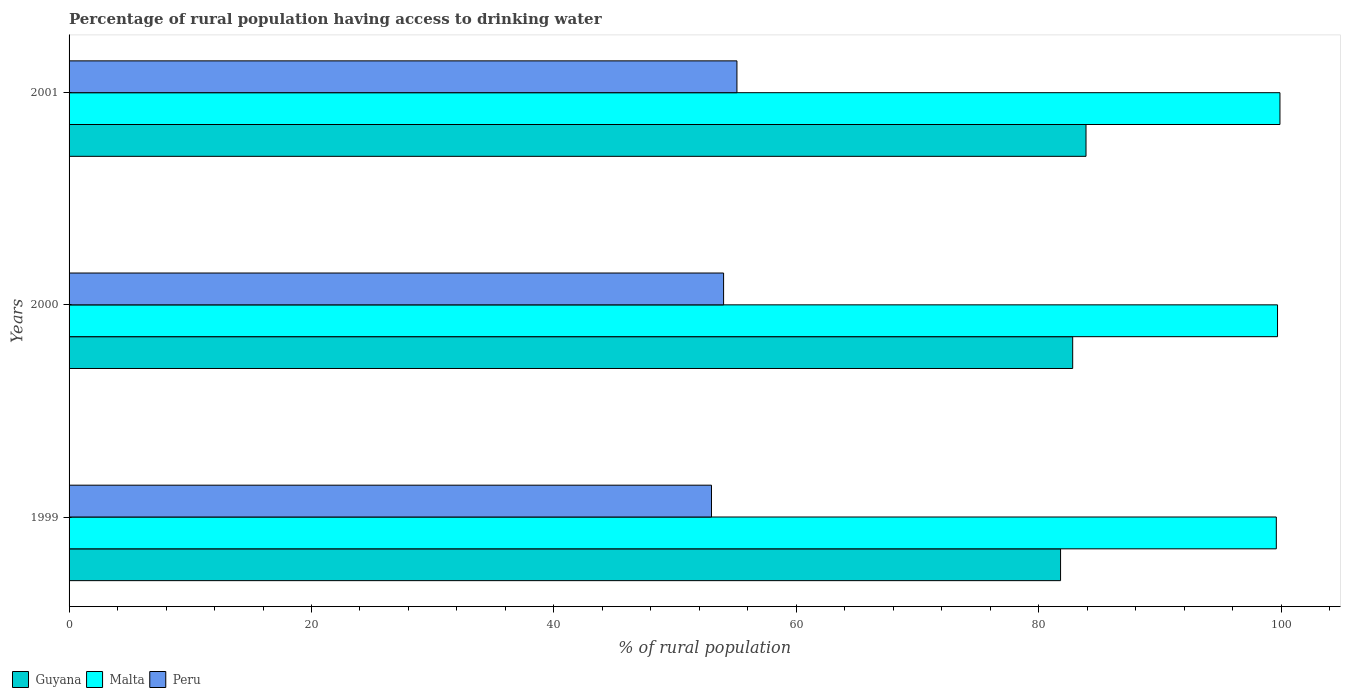How many bars are there on the 2nd tick from the top?
Offer a terse response. 3. In how many cases, is the number of bars for a given year not equal to the number of legend labels?
Ensure brevity in your answer.  0. Across all years, what is the maximum percentage of rural population having access to drinking water in Guyana?
Provide a succinct answer. 83.9. Across all years, what is the minimum percentage of rural population having access to drinking water in Malta?
Your answer should be compact. 99.6. What is the total percentage of rural population having access to drinking water in Malta in the graph?
Make the answer very short. 299.2. What is the difference between the percentage of rural population having access to drinking water in Malta in 1999 and that in 2001?
Your answer should be very brief. -0.3. What is the difference between the percentage of rural population having access to drinking water in Peru in 2000 and the percentage of rural population having access to drinking water in Malta in 2001?
Make the answer very short. -45.9. What is the average percentage of rural population having access to drinking water in Guyana per year?
Your answer should be very brief. 82.83. In the year 2000, what is the difference between the percentage of rural population having access to drinking water in Malta and percentage of rural population having access to drinking water in Guyana?
Your response must be concise. 16.9. In how many years, is the percentage of rural population having access to drinking water in Guyana greater than 40 %?
Provide a short and direct response. 3. What is the ratio of the percentage of rural population having access to drinking water in Peru in 1999 to that in 2001?
Ensure brevity in your answer.  0.96. What is the difference between the highest and the second highest percentage of rural population having access to drinking water in Peru?
Offer a terse response. 1.1. What is the difference between the highest and the lowest percentage of rural population having access to drinking water in Malta?
Provide a short and direct response. 0.3. Is the sum of the percentage of rural population having access to drinking water in Peru in 2000 and 2001 greater than the maximum percentage of rural population having access to drinking water in Malta across all years?
Your answer should be compact. Yes. What does the 3rd bar from the top in 1999 represents?
Offer a very short reply. Guyana. What does the 1st bar from the bottom in 2001 represents?
Your answer should be very brief. Guyana. How many bars are there?
Provide a short and direct response. 9. Are all the bars in the graph horizontal?
Offer a terse response. Yes. How many years are there in the graph?
Provide a succinct answer. 3. Does the graph contain any zero values?
Give a very brief answer. No. Where does the legend appear in the graph?
Make the answer very short. Bottom left. How many legend labels are there?
Offer a terse response. 3. What is the title of the graph?
Make the answer very short. Percentage of rural population having access to drinking water. Does "Latin America(developing only)" appear as one of the legend labels in the graph?
Keep it short and to the point. No. What is the label or title of the X-axis?
Provide a short and direct response. % of rural population. What is the % of rural population of Guyana in 1999?
Your answer should be compact. 81.8. What is the % of rural population in Malta in 1999?
Provide a short and direct response. 99.6. What is the % of rural population in Guyana in 2000?
Keep it short and to the point. 82.8. What is the % of rural population in Malta in 2000?
Your response must be concise. 99.7. What is the % of rural population in Guyana in 2001?
Keep it short and to the point. 83.9. What is the % of rural population in Malta in 2001?
Offer a terse response. 99.9. What is the % of rural population in Peru in 2001?
Keep it short and to the point. 55.1. Across all years, what is the maximum % of rural population in Guyana?
Provide a short and direct response. 83.9. Across all years, what is the maximum % of rural population of Malta?
Your response must be concise. 99.9. Across all years, what is the maximum % of rural population of Peru?
Give a very brief answer. 55.1. Across all years, what is the minimum % of rural population of Guyana?
Your answer should be compact. 81.8. Across all years, what is the minimum % of rural population of Malta?
Your answer should be very brief. 99.6. Across all years, what is the minimum % of rural population in Peru?
Make the answer very short. 53. What is the total % of rural population in Guyana in the graph?
Your answer should be very brief. 248.5. What is the total % of rural population of Malta in the graph?
Provide a short and direct response. 299.2. What is the total % of rural population of Peru in the graph?
Offer a very short reply. 162.1. What is the difference between the % of rural population in Guyana in 1999 and that in 2000?
Provide a short and direct response. -1. What is the difference between the % of rural population in Malta in 1999 and that in 2000?
Provide a succinct answer. -0.1. What is the difference between the % of rural population of Peru in 1999 and that in 2000?
Ensure brevity in your answer.  -1. What is the difference between the % of rural population of Peru in 1999 and that in 2001?
Your answer should be compact. -2.1. What is the difference between the % of rural population of Malta in 2000 and that in 2001?
Your answer should be compact. -0.2. What is the difference between the % of rural population of Peru in 2000 and that in 2001?
Keep it short and to the point. -1.1. What is the difference between the % of rural population in Guyana in 1999 and the % of rural population in Malta in 2000?
Ensure brevity in your answer.  -17.9. What is the difference between the % of rural population in Guyana in 1999 and the % of rural population in Peru in 2000?
Give a very brief answer. 27.8. What is the difference between the % of rural population in Malta in 1999 and the % of rural population in Peru in 2000?
Make the answer very short. 45.6. What is the difference between the % of rural population of Guyana in 1999 and the % of rural population of Malta in 2001?
Make the answer very short. -18.1. What is the difference between the % of rural population of Guyana in 1999 and the % of rural population of Peru in 2001?
Keep it short and to the point. 26.7. What is the difference between the % of rural population of Malta in 1999 and the % of rural population of Peru in 2001?
Provide a succinct answer. 44.5. What is the difference between the % of rural population in Guyana in 2000 and the % of rural population in Malta in 2001?
Make the answer very short. -17.1. What is the difference between the % of rural population of Guyana in 2000 and the % of rural population of Peru in 2001?
Provide a short and direct response. 27.7. What is the difference between the % of rural population in Malta in 2000 and the % of rural population in Peru in 2001?
Give a very brief answer. 44.6. What is the average % of rural population of Guyana per year?
Give a very brief answer. 82.83. What is the average % of rural population of Malta per year?
Ensure brevity in your answer.  99.73. What is the average % of rural population in Peru per year?
Offer a terse response. 54.03. In the year 1999, what is the difference between the % of rural population of Guyana and % of rural population of Malta?
Provide a short and direct response. -17.8. In the year 1999, what is the difference between the % of rural population in Guyana and % of rural population in Peru?
Your answer should be very brief. 28.8. In the year 1999, what is the difference between the % of rural population of Malta and % of rural population of Peru?
Provide a succinct answer. 46.6. In the year 2000, what is the difference between the % of rural population of Guyana and % of rural population of Malta?
Your response must be concise. -16.9. In the year 2000, what is the difference between the % of rural population in Guyana and % of rural population in Peru?
Offer a very short reply. 28.8. In the year 2000, what is the difference between the % of rural population in Malta and % of rural population in Peru?
Offer a terse response. 45.7. In the year 2001, what is the difference between the % of rural population in Guyana and % of rural population in Malta?
Your response must be concise. -16. In the year 2001, what is the difference between the % of rural population in Guyana and % of rural population in Peru?
Your response must be concise. 28.8. In the year 2001, what is the difference between the % of rural population of Malta and % of rural population of Peru?
Provide a succinct answer. 44.8. What is the ratio of the % of rural population of Guyana in 1999 to that in 2000?
Offer a terse response. 0.99. What is the ratio of the % of rural population in Malta in 1999 to that in 2000?
Your answer should be very brief. 1. What is the ratio of the % of rural population in Peru in 1999 to that in 2000?
Keep it short and to the point. 0.98. What is the ratio of the % of rural population in Peru in 1999 to that in 2001?
Offer a very short reply. 0.96. What is the ratio of the % of rural population in Guyana in 2000 to that in 2001?
Keep it short and to the point. 0.99. What is the ratio of the % of rural population in Malta in 2000 to that in 2001?
Your answer should be compact. 1. What is the difference between the highest and the second highest % of rural population of Malta?
Offer a very short reply. 0.2. What is the difference between the highest and the second highest % of rural population in Peru?
Your answer should be compact. 1.1. What is the difference between the highest and the lowest % of rural population of Guyana?
Your answer should be compact. 2.1. What is the difference between the highest and the lowest % of rural population in Malta?
Provide a short and direct response. 0.3. What is the difference between the highest and the lowest % of rural population of Peru?
Your response must be concise. 2.1. 